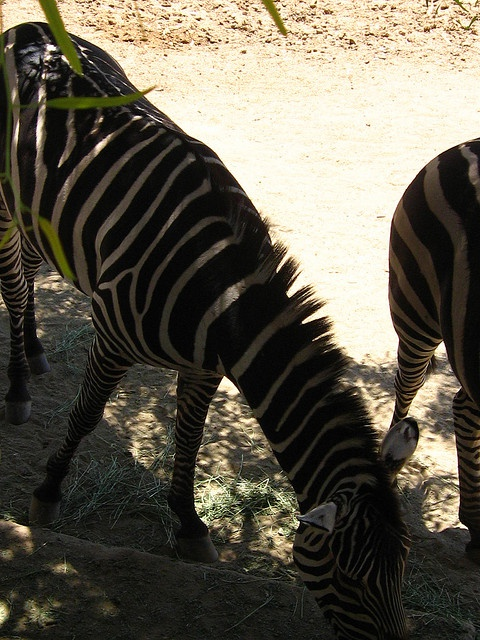Describe the objects in this image and their specific colors. I can see zebra in tan, black, darkgreen, and gray tones and zebra in tan, black, and gray tones in this image. 